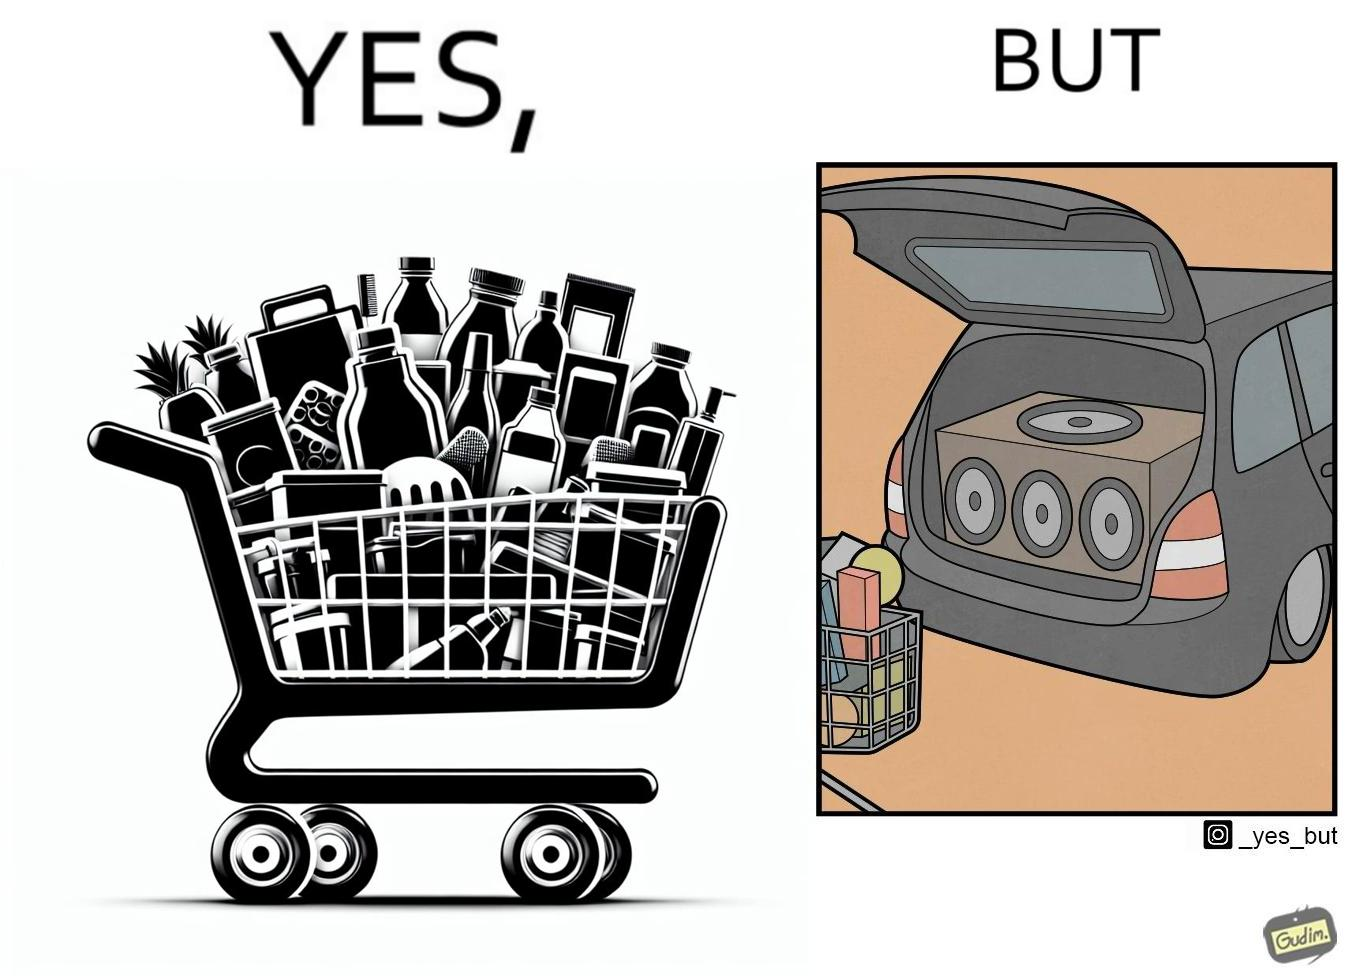Is this image satirical or non-satirical? Yes, this image is satirical. 